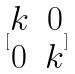<formula> <loc_0><loc_0><loc_500><loc_500>[ \begin{matrix} k & 0 \\ 0 & k \end{matrix} ]</formula> 